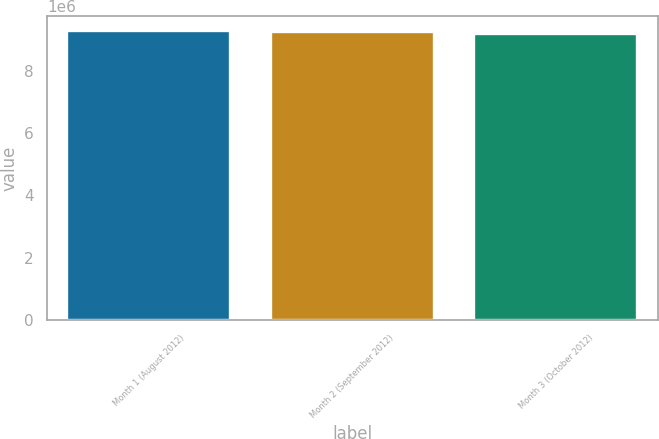Convert chart to OTSL. <chart><loc_0><loc_0><loc_500><loc_500><bar_chart><fcel>Month 1 (August 2012)<fcel>Month 2 (September 2012)<fcel>Month 3 (October 2012)<nl><fcel>9.27846e+06<fcel>9.23513e+06<fcel>9.17601e+06<nl></chart> 